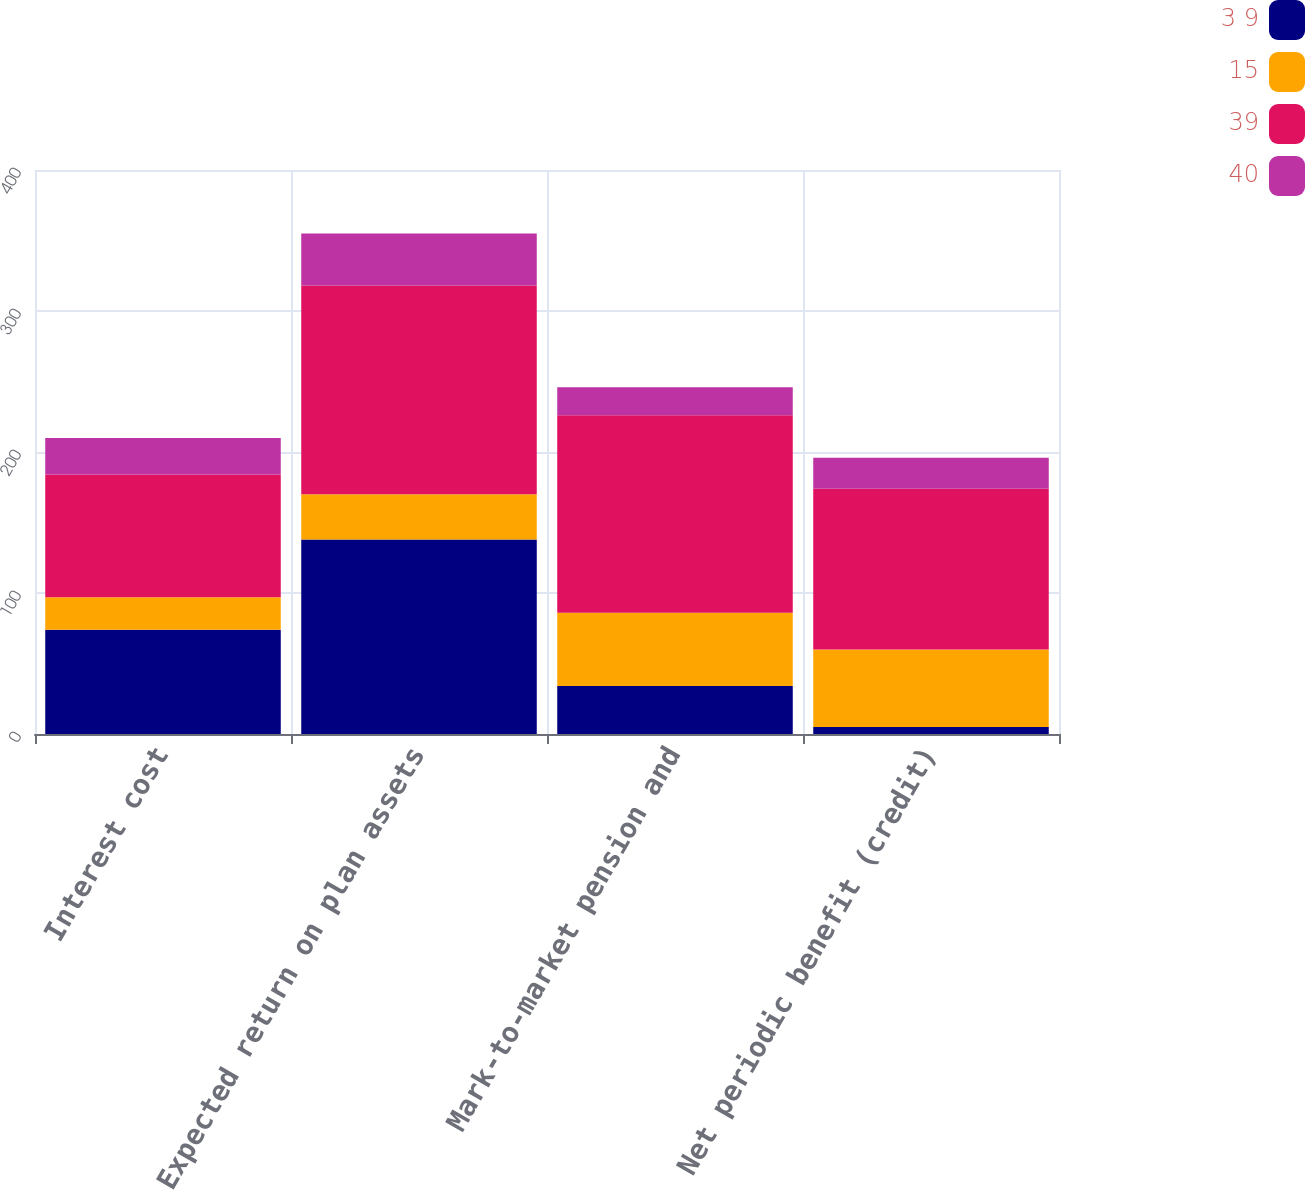<chart> <loc_0><loc_0><loc_500><loc_500><stacked_bar_chart><ecel><fcel>Interest cost<fcel>Expected return on plan assets<fcel>Mark-to-market pension and<fcel>Net periodic benefit (credit)<nl><fcel>3 9<fcel>74<fcel>138<fcel>34<fcel>5<nl><fcel>15<fcel>23<fcel>32<fcel>52<fcel>55<nl><fcel>39<fcel>87<fcel>148<fcel>140<fcel>114<nl><fcel>40<fcel>26<fcel>37<fcel>20<fcel>22<nl></chart> 